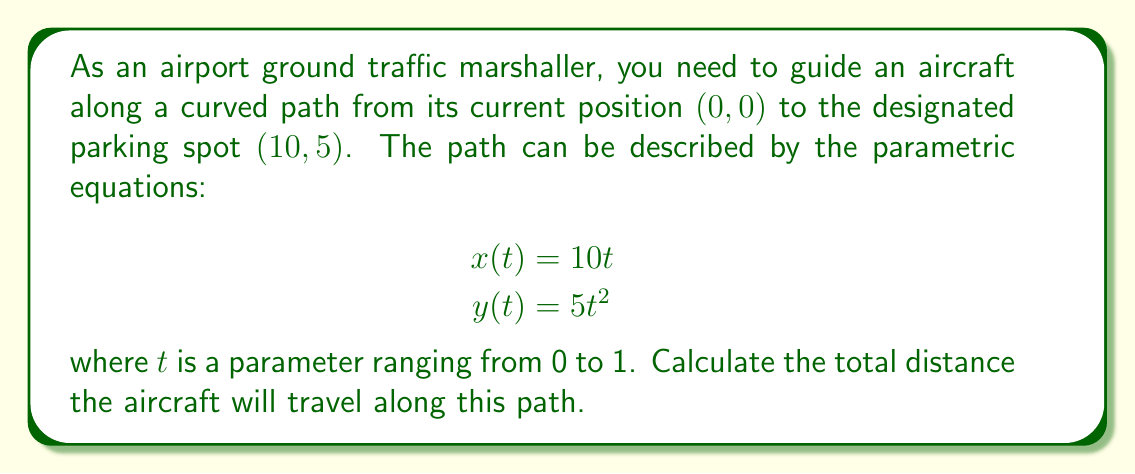Solve this math problem. To find the total distance traveled along the parametric curve, we need to use the arc length formula:

1) The arc length formula for a parametric curve is:

   $$L = \int_{a}^{b} \sqrt{\left(\frac{dx}{dt}\right)^2 + \left(\frac{dy}{dt}\right)^2} dt$$

2) First, let's find $\frac{dx}{dt}$ and $\frac{dy}{dt}$:
   
   $$\frac{dx}{dt} = 10$$
   $$\frac{dy}{dt} = 10t$$

3) Substituting these into the arc length formula:

   $$L = \int_{0}^{1} \sqrt{(10)^2 + (10t)^2} dt$$

4) Simplify under the square root:

   $$L = \int_{0}^{1} \sqrt{100 + 100t^2} dt$$
   $$L = 10\int_{0}^{1} \sqrt{1 + t^2} dt$$

5) This integral doesn't have an elementary antiderivative. We need to use the hyperbolic substitution:

   Let $t = \sinh u$, then $dt = \cosh u \, du$

6) Substituting:

   $$L = 10\int_{0}^{\sinh^{-1}(1)} \sqrt{1 + \sinh^2 u} \cosh u \, du$$

7) Simplify using the identity $1 + \sinh^2 u = \cosh^2 u$:

   $$L = 10\int_{0}^{\sinh^{-1}(1)} \cosh^2 u \, du$$

8) Use the identity $\cosh^2 u = \frac{1 + \cosh(2u)}{2}$:

   $$L = 10\int_{0}^{\sinh^{-1}(1)} \frac{1 + \cosh(2u)}{2} \, du$$

9) Integrate:

   $$L = 10\left[\frac{u}{2} + \frac{\sinh(2u)}{4}\right]_{0}^{\sinh^{-1}(1)}$$

10) Evaluate the bounds:

    $$L = 10\left[\frac{\sinh^{-1}(1)}{2} + \frac{\sinh(2\sinh^{-1}(1))}{4}\right]$$

11) Simplify using the identities $\sinh^{-1}(1) = \ln(\sqrt{2} + 1)$ and $\sinh(2\sinh^{-1}(1)) = 2\sqrt{2}$:

    $$L = 10\left[\frac{\ln(\sqrt{2} + 1)}{2} + \frac{\sqrt{2}}{2}\right]$$
Answer: $5\ln(\sqrt{2} + 1) + 5\sqrt{2}$ 